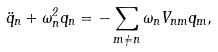<formula> <loc_0><loc_0><loc_500><loc_500>\ddot { q } _ { n } + \omega _ { n } ^ { 2 } q _ { n } = - \sum _ { m \neq n } \omega _ { n } V _ { n m } q _ { m } ,</formula> 